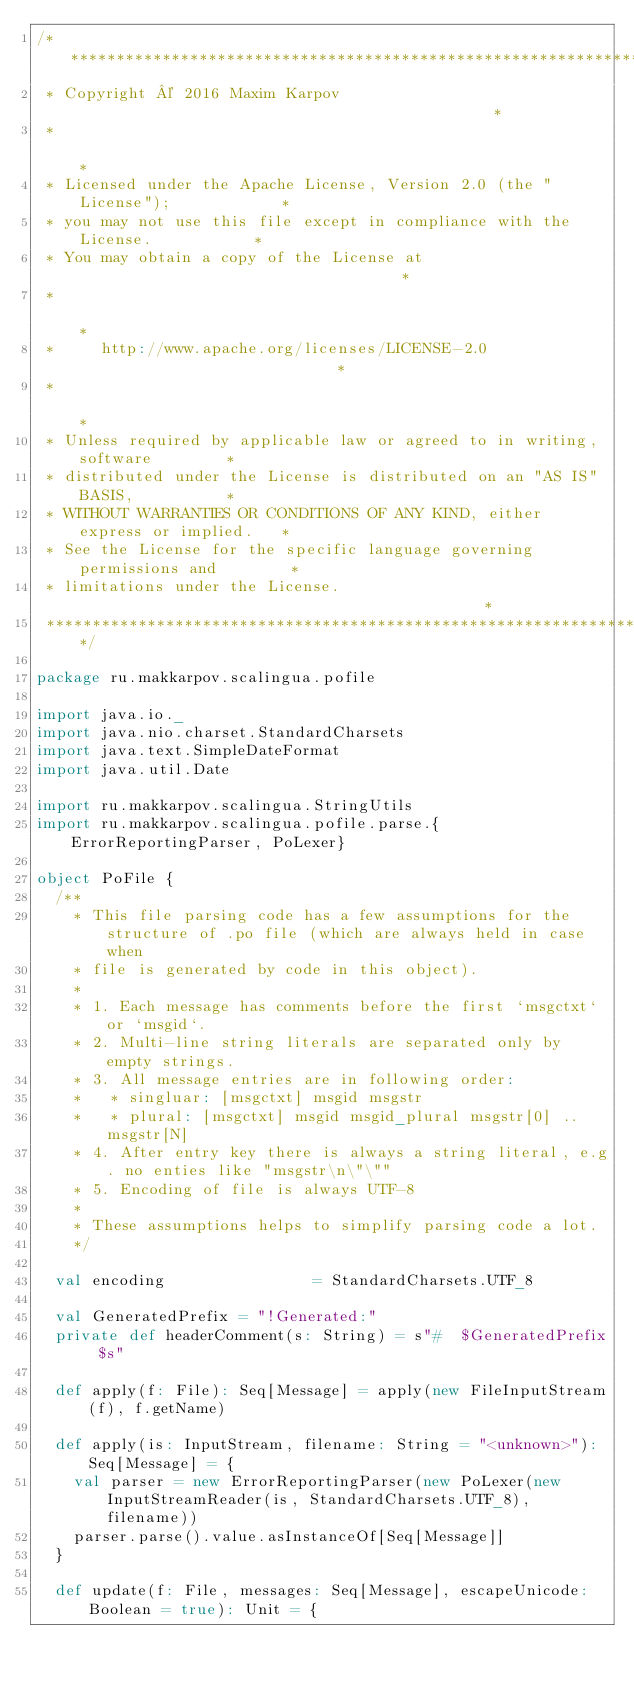<code> <loc_0><loc_0><loc_500><loc_500><_Scala_>/******************************************************************************
 * Copyright © 2016 Maxim Karpov                                              *
 *                                                                            *
 * Licensed under the Apache License, Version 2.0 (the "License");            *
 * you may not use this file except in compliance with the License.           *
 * You may obtain a copy of the License at                                    *
 *                                                                            *
 *     http://www.apache.org/licenses/LICENSE-2.0                             *
 *                                                                            *
 * Unless required by applicable law or agreed to in writing, software        *
 * distributed under the License is distributed on an "AS IS" BASIS,          *
 * WITHOUT WARRANTIES OR CONDITIONS OF ANY KIND, either express or implied.   *
 * See the License for the specific language governing permissions and        *
 * limitations under the License.                                             *
 ******************************************************************************/

package ru.makkarpov.scalingua.pofile

import java.io._
import java.nio.charset.StandardCharsets
import java.text.SimpleDateFormat
import java.util.Date

import ru.makkarpov.scalingua.StringUtils
import ru.makkarpov.scalingua.pofile.parse.{ErrorReportingParser, PoLexer}

object PoFile {
  /**
    * This file parsing code has a few assumptions for the structure of .po file (which are always held in case when
    * file is generated by code in this object).
    *
    * 1. Each message has comments before the first `msgctxt` or `msgid`.
    * 2. Multi-line string literals are separated only by empty strings.
    * 3. All message entries are in following order:
    *   * singluar: [msgctxt] msgid msgstr
    *   * plural: [msgctxt] msgid msgid_plural msgstr[0] .. msgstr[N]
    * 4. After entry key there is always a string literal, e.g. no enties like "msgstr\n\"\""
    * 5. Encoding of file is always UTF-8
    *
    * These assumptions helps to simplify parsing code a lot.
    */

  val encoding                = StandardCharsets.UTF_8

  val GeneratedPrefix = "!Generated:"
  private def headerComment(s: String) = s"#  $GeneratedPrefix $s"

  def apply(f: File): Seq[Message] = apply(new FileInputStream(f), f.getName)

  def apply(is: InputStream, filename: String = "<unknown>"): Seq[Message] = {
    val parser = new ErrorReportingParser(new PoLexer(new InputStreamReader(is, StandardCharsets.UTF_8), filename))
    parser.parse().value.asInstanceOf[Seq[Message]]
  }

  def update(f: File, messages: Seq[Message], escapeUnicode: Boolean = true): Unit = {</code> 